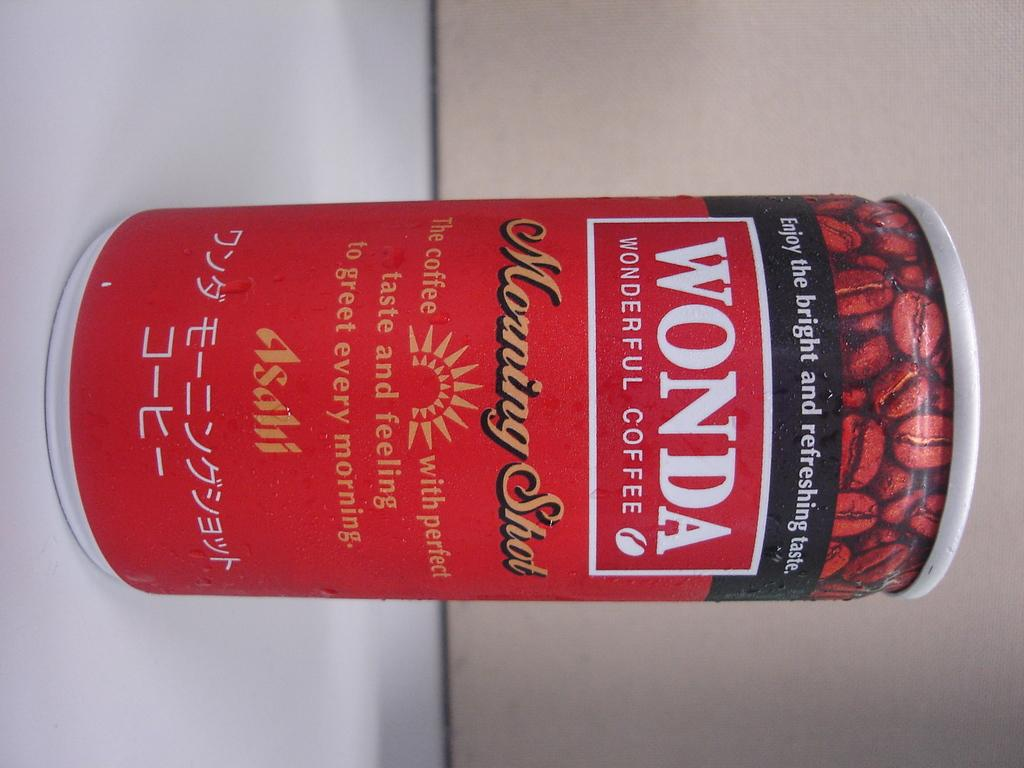Provide a one-sentence caption for the provided image. A can of Wonda wonderful Coffee has the logo Enjoy the bright and refreshing taste on it. 